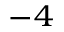<formula> <loc_0><loc_0><loc_500><loc_500>^ { - 4 }</formula> 